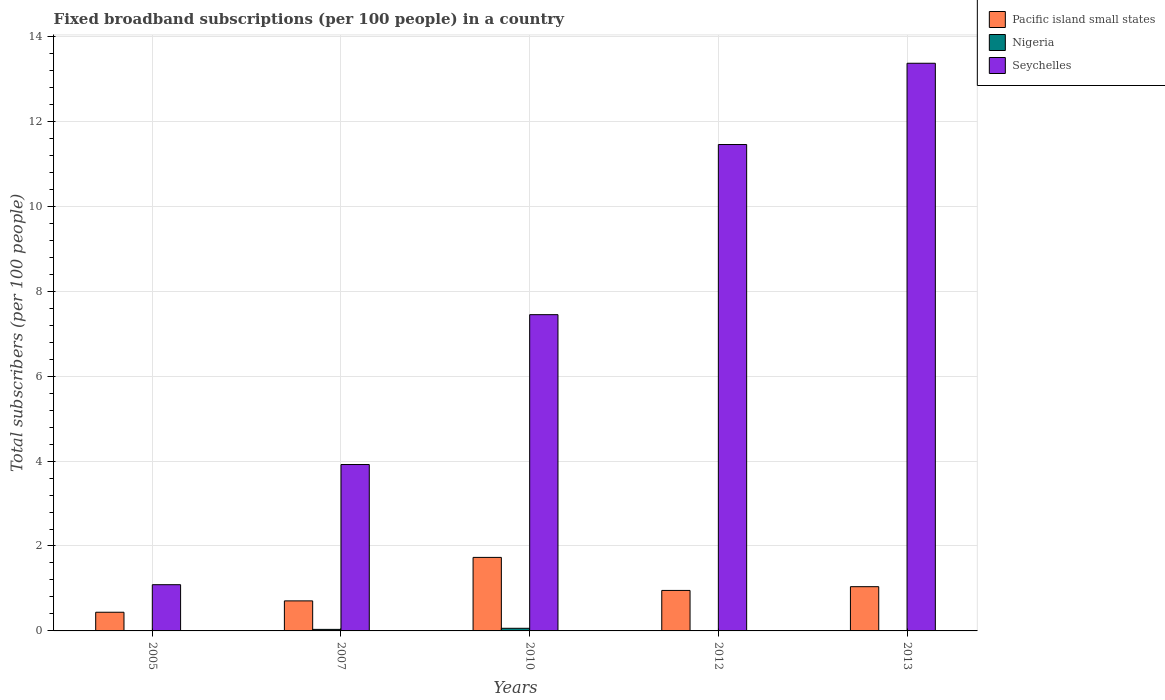How many different coloured bars are there?
Keep it short and to the point. 3. Are the number of bars on each tick of the X-axis equal?
Provide a short and direct response. Yes. How many bars are there on the 5th tick from the left?
Your answer should be compact. 3. In how many cases, is the number of bars for a given year not equal to the number of legend labels?
Keep it short and to the point. 0. What is the number of broadband subscriptions in Pacific island small states in 2010?
Provide a succinct answer. 1.73. Across all years, what is the maximum number of broadband subscriptions in Nigeria?
Keep it short and to the point. 0.06. Across all years, what is the minimum number of broadband subscriptions in Nigeria?
Your answer should be very brief. 0. In which year was the number of broadband subscriptions in Seychelles maximum?
Keep it short and to the point. 2013. In which year was the number of broadband subscriptions in Seychelles minimum?
Your answer should be very brief. 2005. What is the total number of broadband subscriptions in Nigeria in the graph?
Your answer should be very brief. 0.12. What is the difference between the number of broadband subscriptions in Seychelles in 2005 and that in 2010?
Offer a very short reply. -6.36. What is the difference between the number of broadband subscriptions in Pacific island small states in 2010 and the number of broadband subscriptions in Nigeria in 2013?
Ensure brevity in your answer.  1.72. What is the average number of broadband subscriptions in Nigeria per year?
Provide a succinct answer. 0.02. In the year 2012, what is the difference between the number of broadband subscriptions in Seychelles and number of broadband subscriptions in Nigeria?
Offer a terse response. 11.45. What is the ratio of the number of broadband subscriptions in Seychelles in 2007 to that in 2010?
Give a very brief answer. 0.53. Is the difference between the number of broadband subscriptions in Seychelles in 2007 and 2013 greater than the difference between the number of broadband subscriptions in Nigeria in 2007 and 2013?
Keep it short and to the point. No. What is the difference between the highest and the second highest number of broadband subscriptions in Nigeria?
Offer a terse response. 0.03. What is the difference between the highest and the lowest number of broadband subscriptions in Pacific island small states?
Keep it short and to the point. 1.29. Is the sum of the number of broadband subscriptions in Pacific island small states in 2005 and 2012 greater than the maximum number of broadband subscriptions in Seychelles across all years?
Provide a short and direct response. No. What does the 2nd bar from the left in 2007 represents?
Provide a short and direct response. Nigeria. What does the 2nd bar from the right in 2012 represents?
Offer a terse response. Nigeria. Are all the bars in the graph horizontal?
Provide a succinct answer. No. Where does the legend appear in the graph?
Ensure brevity in your answer.  Top right. How many legend labels are there?
Ensure brevity in your answer.  3. What is the title of the graph?
Keep it short and to the point. Fixed broadband subscriptions (per 100 people) in a country. Does "Isle of Man" appear as one of the legend labels in the graph?
Provide a succinct answer. No. What is the label or title of the Y-axis?
Make the answer very short. Total subscribers (per 100 people). What is the Total subscribers (per 100 people) in Pacific island small states in 2005?
Offer a very short reply. 0.44. What is the Total subscribers (per 100 people) of Nigeria in 2005?
Provide a succinct answer. 0. What is the Total subscribers (per 100 people) in Seychelles in 2005?
Keep it short and to the point. 1.09. What is the Total subscribers (per 100 people) of Pacific island small states in 2007?
Offer a terse response. 0.71. What is the Total subscribers (per 100 people) of Nigeria in 2007?
Your response must be concise. 0.04. What is the Total subscribers (per 100 people) of Seychelles in 2007?
Your answer should be very brief. 3.92. What is the Total subscribers (per 100 people) in Pacific island small states in 2010?
Offer a terse response. 1.73. What is the Total subscribers (per 100 people) of Nigeria in 2010?
Give a very brief answer. 0.06. What is the Total subscribers (per 100 people) in Seychelles in 2010?
Your answer should be compact. 7.45. What is the Total subscribers (per 100 people) in Pacific island small states in 2012?
Provide a short and direct response. 0.95. What is the Total subscribers (per 100 people) of Nigeria in 2012?
Provide a succinct answer. 0.01. What is the Total subscribers (per 100 people) of Seychelles in 2012?
Your answer should be compact. 11.45. What is the Total subscribers (per 100 people) in Pacific island small states in 2013?
Keep it short and to the point. 1.04. What is the Total subscribers (per 100 people) in Nigeria in 2013?
Ensure brevity in your answer.  0.01. What is the Total subscribers (per 100 people) of Seychelles in 2013?
Offer a terse response. 13.37. Across all years, what is the maximum Total subscribers (per 100 people) of Pacific island small states?
Offer a terse response. 1.73. Across all years, what is the maximum Total subscribers (per 100 people) in Nigeria?
Make the answer very short. 0.06. Across all years, what is the maximum Total subscribers (per 100 people) of Seychelles?
Your answer should be compact. 13.37. Across all years, what is the minimum Total subscribers (per 100 people) in Pacific island small states?
Offer a very short reply. 0.44. Across all years, what is the minimum Total subscribers (per 100 people) in Nigeria?
Offer a terse response. 0. Across all years, what is the minimum Total subscribers (per 100 people) of Seychelles?
Make the answer very short. 1.09. What is the total Total subscribers (per 100 people) of Pacific island small states in the graph?
Your answer should be compact. 4.87. What is the total Total subscribers (per 100 people) of Nigeria in the graph?
Provide a short and direct response. 0.12. What is the total Total subscribers (per 100 people) in Seychelles in the graph?
Provide a succinct answer. 37.28. What is the difference between the Total subscribers (per 100 people) in Pacific island small states in 2005 and that in 2007?
Keep it short and to the point. -0.27. What is the difference between the Total subscribers (per 100 people) in Nigeria in 2005 and that in 2007?
Your response must be concise. -0.04. What is the difference between the Total subscribers (per 100 people) of Seychelles in 2005 and that in 2007?
Give a very brief answer. -2.83. What is the difference between the Total subscribers (per 100 people) in Pacific island small states in 2005 and that in 2010?
Offer a very short reply. -1.29. What is the difference between the Total subscribers (per 100 people) of Nigeria in 2005 and that in 2010?
Your answer should be very brief. -0.06. What is the difference between the Total subscribers (per 100 people) of Seychelles in 2005 and that in 2010?
Provide a succinct answer. -6.36. What is the difference between the Total subscribers (per 100 people) in Pacific island small states in 2005 and that in 2012?
Give a very brief answer. -0.51. What is the difference between the Total subscribers (per 100 people) in Nigeria in 2005 and that in 2012?
Give a very brief answer. -0.01. What is the difference between the Total subscribers (per 100 people) of Seychelles in 2005 and that in 2012?
Provide a short and direct response. -10.37. What is the difference between the Total subscribers (per 100 people) in Pacific island small states in 2005 and that in 2013?
Provide a succinct answer. -0.6. What is the difference between the Total subscribers (per 100 people) in Nigeria in 2005 and that in 2013?
Ensure brevity in your answer.  -0.01. What is the difference between the Total subscribers (per 100 people) of Seychelles in 2005 and that in 2013?
Your answer should be compact. -12.28. What is the difference between the Total subscribers (per 100 people) in Pacific island small states in 2007 and that in 2010?
Keep it short and to the point. -1.02. What is the difference between the Total subscribers (per 100 people) of Nigeria in 2007 and that in 2010?
Make the answer very short. -0.03. What is the difference between the Total subscribers (per 100 people) of Seychelles in 2007 and that in 2010?
Make the answer very short. -3.53. What is the difference between the Total subscribers (per 100 people) of Pacific island small states in 2007 and that in 2012?
Provide a succinct answer. -0.25. What is the difference between the Total subscribers (per 100 people) in Nigeria in 2007 and that in 2012?
Your answer should be compact. 0.03. What is the difference between the Total subscribers (per 100 people) in Seychelles in 2007 and that in 2012?
Make the answer very short. -7.54. What is the difference between the Total subscribers (per 100 people) of Pacific island small states in 2007 and that in 2013?
Ensure brevity in your answer.  -0.33. What is the difference between the Total subscribers (per 100 people) of Nigeria in 2007 and that in 2013?
Your response must be concise. 0.03. What is the difference between the Total subscribers (per 100 people) in Seychelles in 2007 and that in 2013?
Make the answer very short. -9.45. What is the difference between the Total subscribers (per 100 people) of Nigeria in 2010 and that in 2012?
Offer a very short reply. 0.05. What is the difference between the Total subscribers (per 100 people) in Seychelles in 2010 and that in 2012?
Keep it short and to the point. -4.01. What is the difference between the Total subscribers (per 100 people) in Pacific island small states in 2010 and that in 2013?
Your response must be concise. 0.69. What is the difference between the Total subscribers (per 100 people) of Nigeria in 2010 and that in 2013?
Offer a terse response. 0.05. What is the difference between the Total subscribers (per 100 people) of Seychelles in 2010 and that in 2013?
Give a very brief answer. -5.92. What is the difference between the Total subscribers (per 100 people) of Pacific island small states in 2012 and that in 2013?
Ensure brevity in your answer.  -0.09. What is the difference between the Total subscribers (per 100 people) of Nigeria in 2012 and that in 2013?
Provide a succinct answer. -0. What is the difference between the Total subscribers (per 100 people) of Seychelles in 2012 and that in 2013?
Provide a succinct answer. -1.91. What is the difference between the Total subscribers (per 100 people) of Pacific island small states in 2005 and the Total subscribers (per 100 people) of Nigeria in 2007?
Your answer should be very brief. 0.4. What is the difference between the Total subscribers (per 100 people) of Pacific island small states in 2005 and the Total subscribers (per 100 people) of Seychelles in 2007?
Your response must be concise. -3.48. What is the difference between the Total subscribers (per 100 people) in Nigeria in 2005 and the Total subscribers (per 100 people) in Seychelles in 2007?
Offer a very short reply. -3.92. What is the difference between the Total subscribers (per 100 people) of Pacific island small states in 2005 and the Total subscribers (per 100 people) of Nigeria in 2010?
Provide a short and direct response. 0.38. What is the difference between the Total subscribers (per 100 people) in Pacific island small states in 2005 and the Total subscribers (per 100 people) in Seychelles in 2010?
Offer a very short reply. -7.01. What is the difference between the Total subscribers (per 100 people) of Nigeria in 2005 and the Total subscribers (per 100 people) of Seychelles in 2010?
Give a very brief answer. -7.45. What is the difference between the Total subscribers (per 100 people) in Pacific island small states in 2005 and the Total subscribers (per 100 people) in Nigeria in 2012?
Make the answer very short. 0.43. What is the difference between the Total subscribers (per 100 people) in Pacific island small states in 2005 and the Total subscribers (per 100 people) in Seychelles in 2012?
Your answer should be very brief. -11.01. What is the difference between the Total subscribers (per 100 people) in Nigeria in 2005 and the Total subscribers (per 100 people) in Seychelles in 2012?
Offer a terse response. -11.45. What is the difference between the Total subscribers (per 100 people) of Pacific island small states in 2005 and the Total subscribers (per 100 people) of Nigeria in 2013?
Your answer should be compact. 0.43. What is the difference between the Total subscribers (per 100 people) of Pacific island small states in 2005 and the Total subscribers (per 100 people) of Seychelles in 2013?
Your response must be concise. -12.93. What is the difference between the Total subscribers (per 100 people) in Nigeria in 2005 and the Total subscribers (per 100 people) in Seychelles in 2013?
Your response must be concise. -13.37. What is the difference between the Total subscribers (per 100 people) in Pacific island small states in 2007 and the Total subscribers (per 100 people) in Nigeria in 2010?
Ensure brevity in your answer.  0.65. What is the difference between the Total subscribers (per 100 people) in Pacific island small states in 2007 and the Total subscribers (per 100 people) in Seychelles in 2010?
Provide a succinct answer. -6.74. What is the difference between the Total subscribers (per 100 people) of Nigeria in 2007 and the Total subscribers (per 100 people) of Seychelles in 2010?
Your response must be concise. -7.41. What is the difference between the Total subscribers (per 100 people) in Pacific island small states in 2007 and the Total subscribers (per 100 people) in Nigeria in 2012?
Provide a succinct answer. 0.7. What is the difference between the Total subscribers (per 100 people) of Pacific island small states in 2007 and the Total subscribers (per 100 people) of Seychelles in 2012?
Ensure brevity in your answer.  -10.75. What is the difference between the Total subscribers (per 100 people) of Nigeria in 2007 and the Total subscribers (per 100 people) of Seychelles in 2012?
Offer a terse response. -11.42. What is the difference between the Total subscribers (per 100 people) of Pacific island small states in 2007 and the Total subscribers (per 100 people) of Nigeria in 2013?
Ensure brevity in your answer.  0.7. What is the difference between the Total subscribers (per 100 people) in Pacific island small states in 2007 and the Total subscribers (per 100 people) in Seychelles in 2013?
Keep it short and to the point. -12.66. What is the difference between the Total subscribers (per 100 people) in Nigeria in 2007 and the Total subscribers (per 100 people) in Seychelles in 2013?
Offer a very short reply. -13.33. What is the difference between the Total subscribers (per 100 people) of Pacific island small states in 2010 and the Total subscribers (per 100 people) of Nigeria in 2012?
Your answer should be very brief. 1.72. What is the difference between the Total subscribers (per 100 people) in Pacific island small states in 2010 and the Total subscribers (per 100 people) in Seychelles in 2012?
Offer a very short reply. -9.72. What is the difference between the Total subscribers (per 100 people) of Nigeria in 2010 and the Total subscribers (per 100 people) of Seychelles in 2012?
Provide a short and direct response. -11.39. What is the difference between the Total subscribers (per 100 people) of Pacific island small states in 2010 and the Total subscribers (per 100 people) of Nigeria in 2013?
Give a very brief answer. 1.72. What is the difference between the Total subscribers (per 100 people) of Pacific island small states in 2010 and the Total subscribers (per 100 people) of Seychelles in 2013?
Your response must be concise. -11.64. What is the difference between the Total subscribers (per 100 people) in Nigeria in 2010 and the Total subscribers (per 100 people) in Seychelles in 2013?
Keep it short and to the point. -13.31. What is the difference between the Total subscribers (per 100 people) in Pacific island small states in 2012 and the Total subscribers (per 100 people) in Nigeria in 2013?
Your answer should be very brief. 0.94. What is the difference between the Total subscribers (per 100 people) in Pacific island small states in 2012 and the Total subscribers (per 100 people) in Seychelles in 2013?
Make the answer very short. -12.41. What is the difference between the Total subscribers (per 100 people) in Nigeria in 2012 and the Total subscribers (per 100 people) in Seychelles in 2013?
Your response must be concise. -13.36. What is the average Total subscribers (per 100 people) in Pacific island small states per year?
Offer a terse response. 0.97. What is the average Total subscribers (per 100 people) of Nigeria per year?
Ensure brevity in your answer.  0.02. What is the average Total subscribers (per 100 people) in Seychelles per year?
Provide a short and direct response. 7.46. In the year 2005, what is the difference between the Total subscribers (per 100 people) in Pacific island small states and Total subscribers (per 100 people) in Nigeria?
Ensure brevity in your answer.  0.44. In the year 2005, what is the difference between the Total subscribers (per 100 people) in Pacific island small states and Total subscribers (per 100 people) in Seychelles?
Provide a succinct answer. -0.65. In the year 2005, what is the difference between the Total subscribers (per 100 people) of Nigeria and Total subscribers (per 100 people) of Seychelles?
Your answer should be very brief. -1.09. In the year 2007, what is the difference between the Total subscribers (per 100 people) in Pacific island small states and Total subscribers (per 100 people) in Nigeria?
Ensure brevity in your answer.  0.67. In the year 2007, what is the difference between the Total subscribers (per 100 people) of Pacific island small states and Total subscribers (per 100 people) of Seychelles?
Make the answer very short. -3.21. In the year 2007, what is the difference between the Total subscribers (per 100 people) in Nigeria and Total subscribers (per 100 people) in Seychelles?
Give a very brief answer. -3.88. In the year 2010, what is the difference between the Total subscribers (per 100 people) in Pacific island small states and Total subscribers (per 100 people) in Nigeria?
Make the answer very short. 1.67. In the year 2010, what is the difference between the Total subscribers (per 100 people) in Pacific island small states and Total subscribers (per 100 people) in Seychelles?
Make the answer very short. -5.72. In the year 2010, what is the difference between the Total subscribers (per 100 people) of Nigeria and Total subscribers (per 100 people) of Seychelles?
Provide a succinct answer. -7.39. In the year 2012, what is the difference between the Total subscribers (per 100 people) in Pacific island small states and Total subscribers (per 100 people) in Nigeria?
Your answer should be compact. 0.95. In the year 2012, what is the difference between the Total subscribers (per 100 people) of Pacific island small states and Total subscribers (per 100 people) of Seychelles?
Your answer should be very brief. -10.5. In the year 2012, what is the difference between the Total subscribers (per 100 people) of Nigeria and Total subscribers (per 100 people) of Seychelles?
Your response must be concise. -11.45. In the year 2013, what is the difference between the Total subscribers (per 100 people) in Pacific island small states and Total subscribers (per 100 people) in Nigeria?
Offer a very short reply. 1.03. In the year 2013, what is the difference between the Total subscribers (per 100 people) of Pacific island small states and Total subscribers (per 100 people) of Seychelles?
Keep it short and to the point. -12.33. In the year 2013, what is the difference between the Total subscribers (per 100 people) in Nigeria and Total subscribers (per 100 people) in Seychelles?
Provide a succinct answer. -13.36. What is the ratio of the Total subscribers (per 100 people) of Pacific island small states in 2005 to that in 2007?
Give a very brief answer. 0.62. What is the ratio of the Total subscribers (per 100 people) in Nigeria in 2005 to that in 2007?
Make the answer very short. 0.01. What is the ratio of the Total subscribers (per 100 people) of Seychelles in 2005 to that in 2007?
Provide a short and direct response. 0.28. What is the ratio of the Total subscribers (per 100 people) in Pacific island small states in 2005 to that in 2010?
Provide a succinct answer. 0.25. What is the ratio of the Total subscribers (per 100 people) of Nigeria in 2005 to that in 2010?
Offer a terse response. 0.01. What is the ratio of the Total subscribers (per 100 people) of Seychelles in 2005 to that in 2010?
Make the answer very short. 0.15. What is the ratio of the Total subscribers (per 100 people) of Pacific island small states in 2005 to that in 2012?
Make the answer very short. 0.46. What is the ratio of the Total subscribers (per 100 people) in Nigeria in 2005 to that in 2012?
Make the answer very short. 0.04. What is the ratio of the Total subscribers (per 100 people) of Seychelles in 2005 to that in 2012?
Keep it short and to the point. 0.1. What is the ratio of the Total subscribers (per 100 people) in Pacific island small states in 2005 to that in 2013?
Your response must be concise. 0.42. What is the ratio of the Total subscribers (per 100 people) in Nigeria in 2005 to that in 2013?
Provide a succinct answer. 0.04. What is the ratio of the Total subscribers (per 100 people) in Seychelles in 2005 to that in 2013?
Offer a terse response. 0.08. What is the ratio of the Total subscribers (per 100 people) in Pacific island small states in 2007 to that in 2010?
Provide a short and direct response. 0.41. What is the ratio of the Total subscribers (per 100 people) of Nigeria in 2007 to that in 2010?
Make the answer very short. 0.59. What is the ratio of the Total subscribers (per 100 people) in Seychelles in 2007 to that in 2010?
Make the answer very short. 0.53. What is the ratio of the Total subscribers (per 100 people) of Pacific island small states in 2007 to that in 2012?
Your response must be concise. 0.74. What is the ratio of the Total subscribers (per 100 people) in Nigeria in 2007 to that in 2012?
Your response must be concise. 4.31. What is the ratio of the Total subscribers (per 100 people) of Seychelles in 2007 to that in 2012?
Your response must be concise. 0.34. What is the ratio of the Total subscribers (per 100 people) in Pacific island small states in 2007 to that in 2013?
Your answer should be very brief. 0.68. What is the ratio of the Total subscribers (per 100 people) in Nigeria in 2007 to that in 2013?
Your response must be concise. 4.2. What is the ratio of the Total subscribers (per 100 people) of Seychelles in 2007 to that in 2013?
Offer a terse response. 0.29. What is the ratio of the Total subscribers (per 100 people) in Pacific island small states in 2010 to that in 2012?
Offer a very short reply. 1.82. What is the ratio of the Total subscribers (per 100 people) of Nigeria in 2010 to that in 2012?
Offer a terse response. 7.34. What is the ratio of the Total subscribers (per 100 people) of Seychelles in 2010 to that in 2012?
Give a very brief answer. 0.65. What is the ratio of the Total subscribers (per 100 people) of Pacific island small states in 2010 to that in 2013?
Keep it short and to the point. 1.66. What is the ratio of the Total subscribers (per 100 people) of Nigeria in 2010 to that in 2013?
Your answer should be compact. 7.16. What is the ratio of the Total subscribers (per 100 people) in Seychelles in 2010 to that in 2013?
Your answer should be very brief. 0.56. What is the ratio of the Total subscribers (per 100 people) of Pacific island small states in 2012 to that in 2013?
Your response must be concise. 0.92. What is the ratio of the Total subscribers (per 100 people) of Nigeria in 2012 to that in 2013?
Your answer should be compact. 0.98. What is the ratio of the Total subscribers (per 100 people) in Seychelles in 2012 to that in 2013?
Ensure brevity in your answer.  0.86. What is the difference between the highest and the second highest Total subscribers (per 100 people) of Pacific island small states?
Your answer should be compact. 0.69. What is the difference between the highest and the second highest Total subscribers (per 100 people) in Nigeria?
Your answer should be very brief. 0.03. What is the difference between the highest and the second highest Total subscribers (per 100 people) of Seychelles?
Your answer should be very brief. 1.91. What is the difference between the highest and the lowest Total subscribers (per 100 people) of Pacific island small states?
Keep it short and to the point. 1.29. What is the difference between the highest and the lowest Total subscribers (per 100 people) of Nigeria?
Make the answer very short. 0.06. What is the difference between the highest and the lowest Total subscribers (per 100 people) in Seychelles?
Your answer should be very brief. 12.28. 